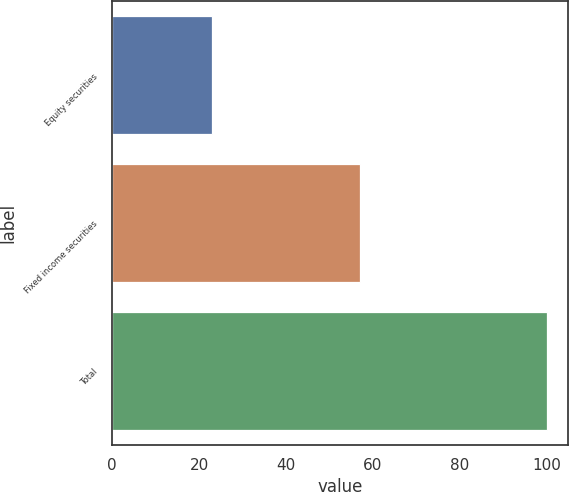<chart> <loc_0><loc_0><loc_500><loc_500><bar_chart><fcel>Equity securities<fcel>Fixed income securities<fcel>Total<nl><fcel>23<fcel>57<fcel>100<nl></chart> 